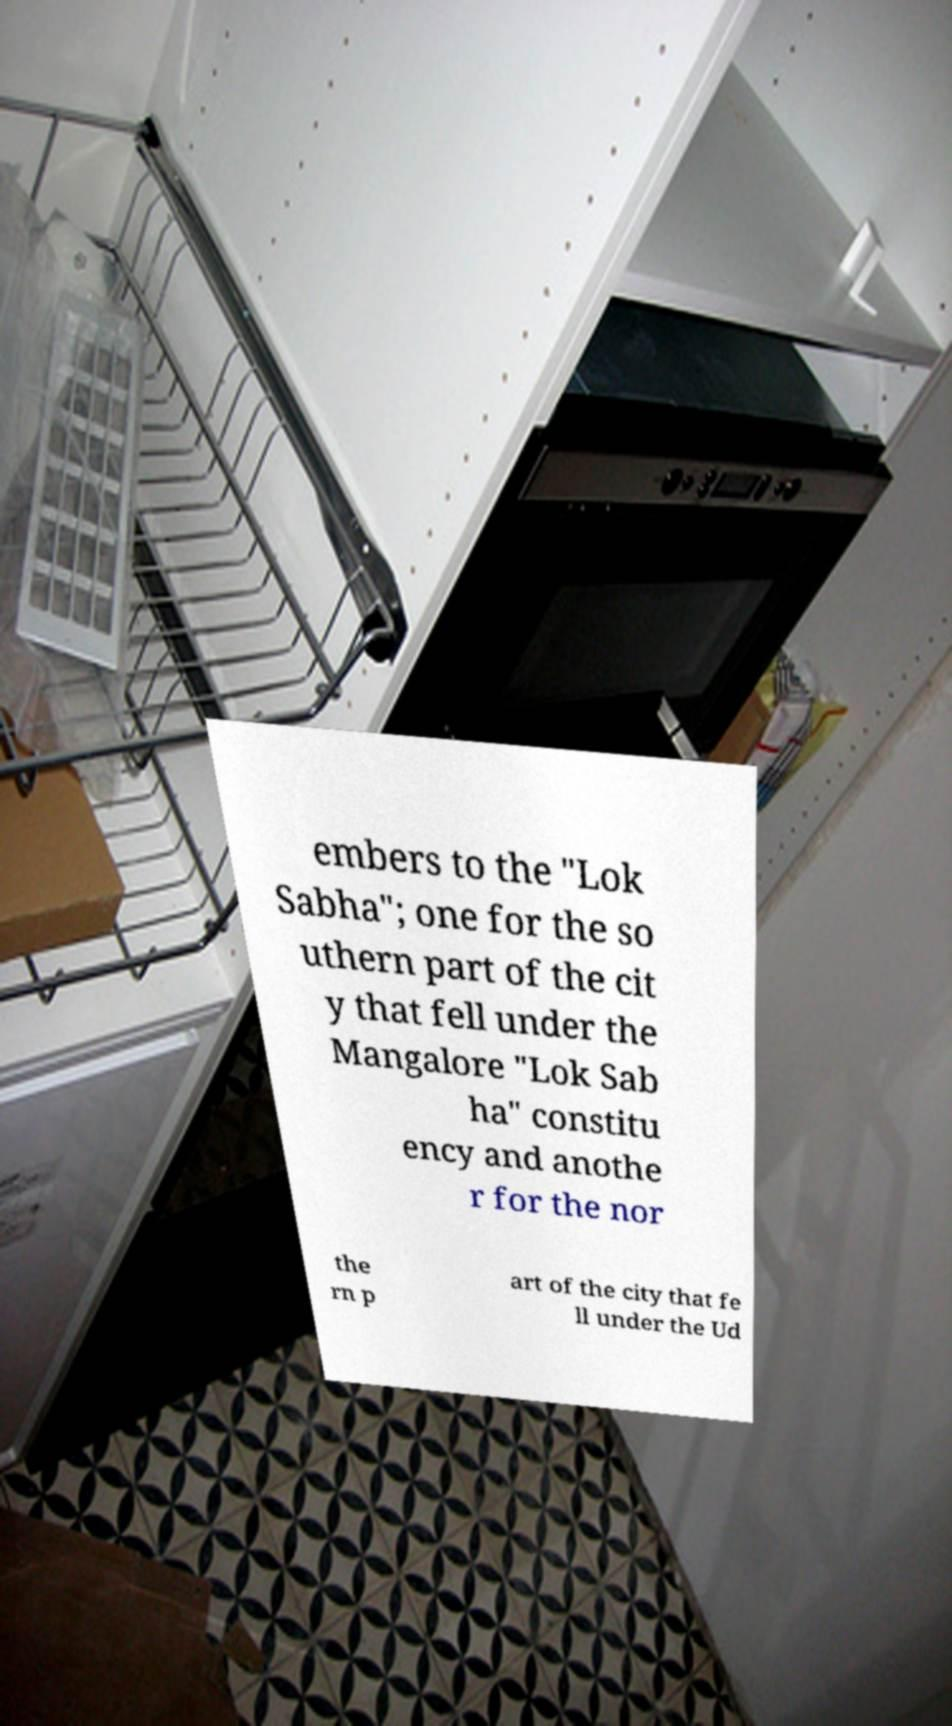Could you extract and type out the text from this image? embers to the "Lok Sabha"; one for the so uthern part of the cit y that fell under the Mangalore "Lok Sab ha" constitu ency and anothe r for the nor the rn p art of the city that fe ll under the Ud 